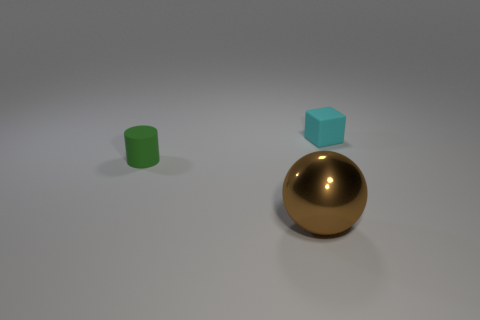Add 1 tiny blue matte things. How many objects exist? 4 Subtract 1 cubes. How many cubes are left? 0 Subtract all balls. How many objects are left? 2 Subtract all shiny balls. Subtract all small rubber cylinders. How many objects are left? 1 Add 3 cyan rubber objects. How many cyan rubber objects are left? 4 Add 1 big rubber cubes. How many big rubber cubes exist? 1 Subtract 0 brown cylinders. How many objects are left? 3 Subtract all brown cylinders. Subtract all purple cubes. How many cylinders are left? 1 